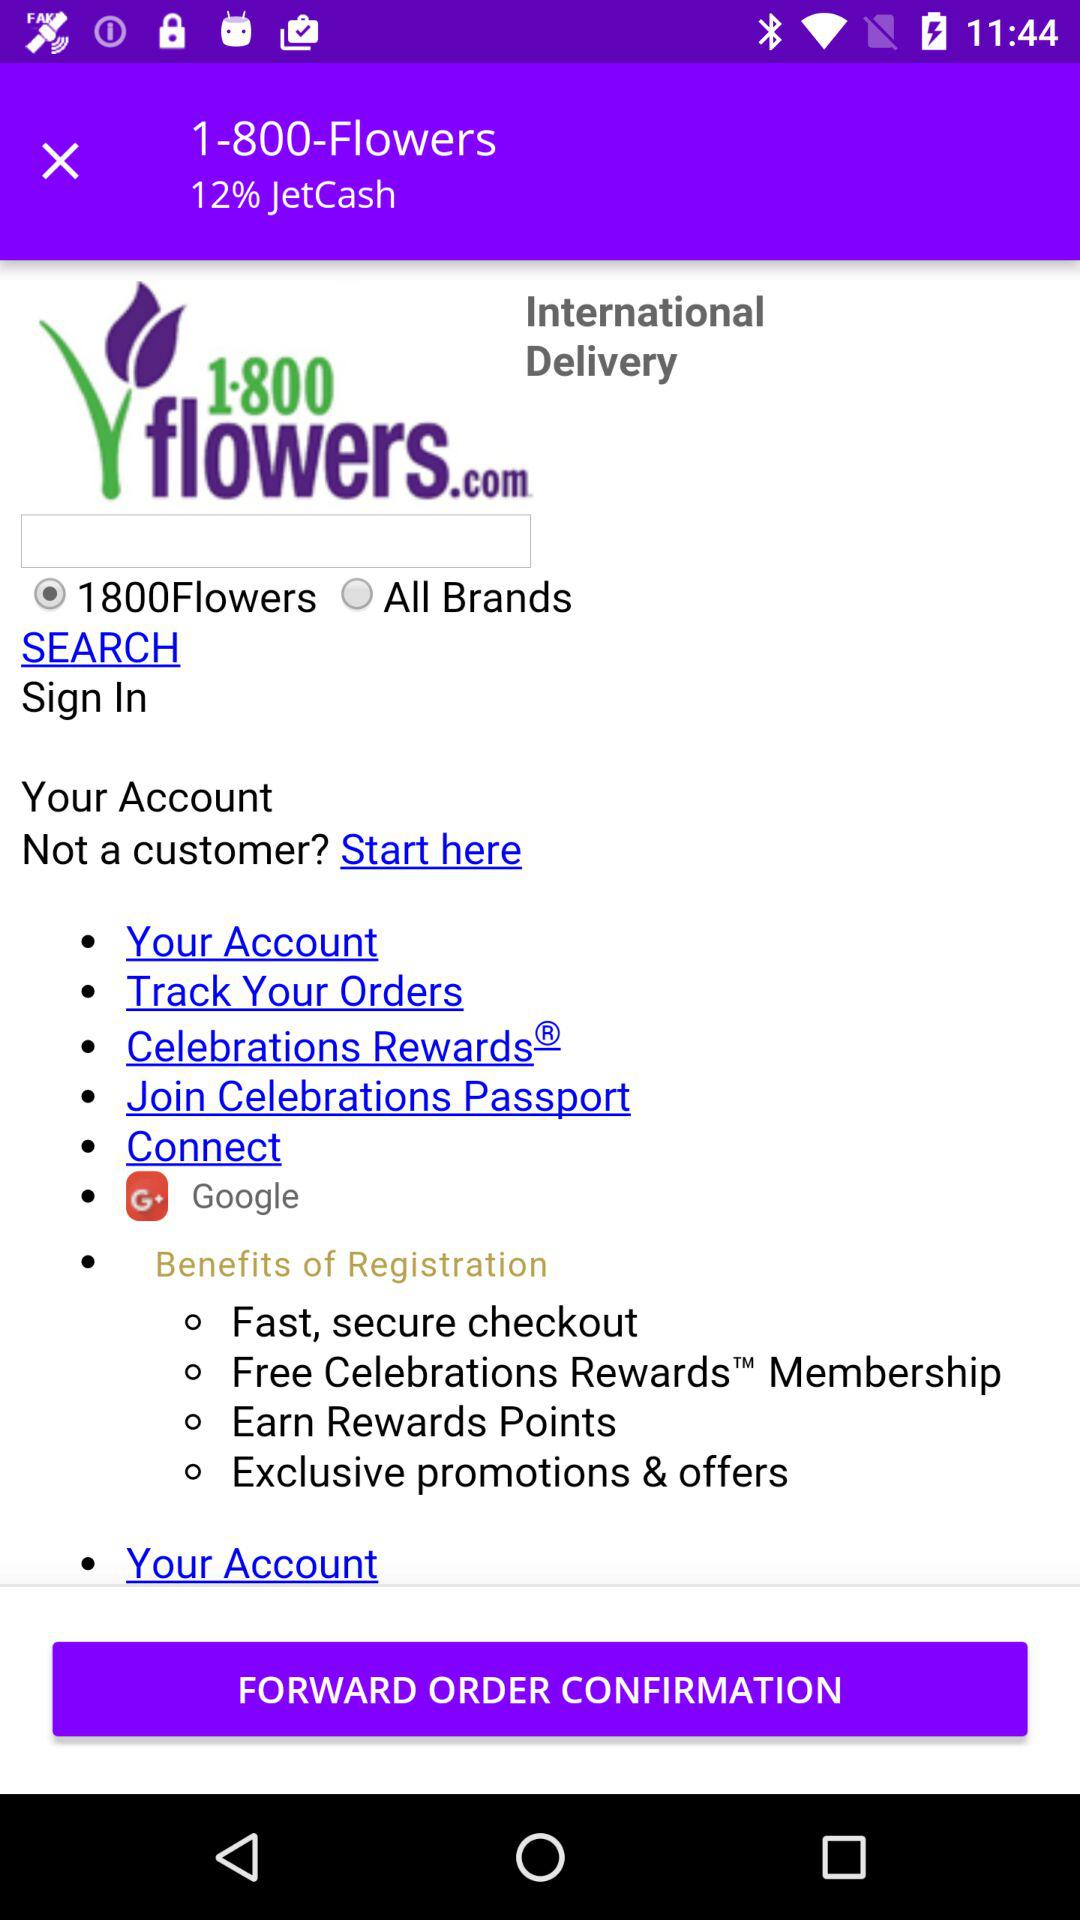What brand option is currently selected? The currently selected brand option is "1800Flowers". 